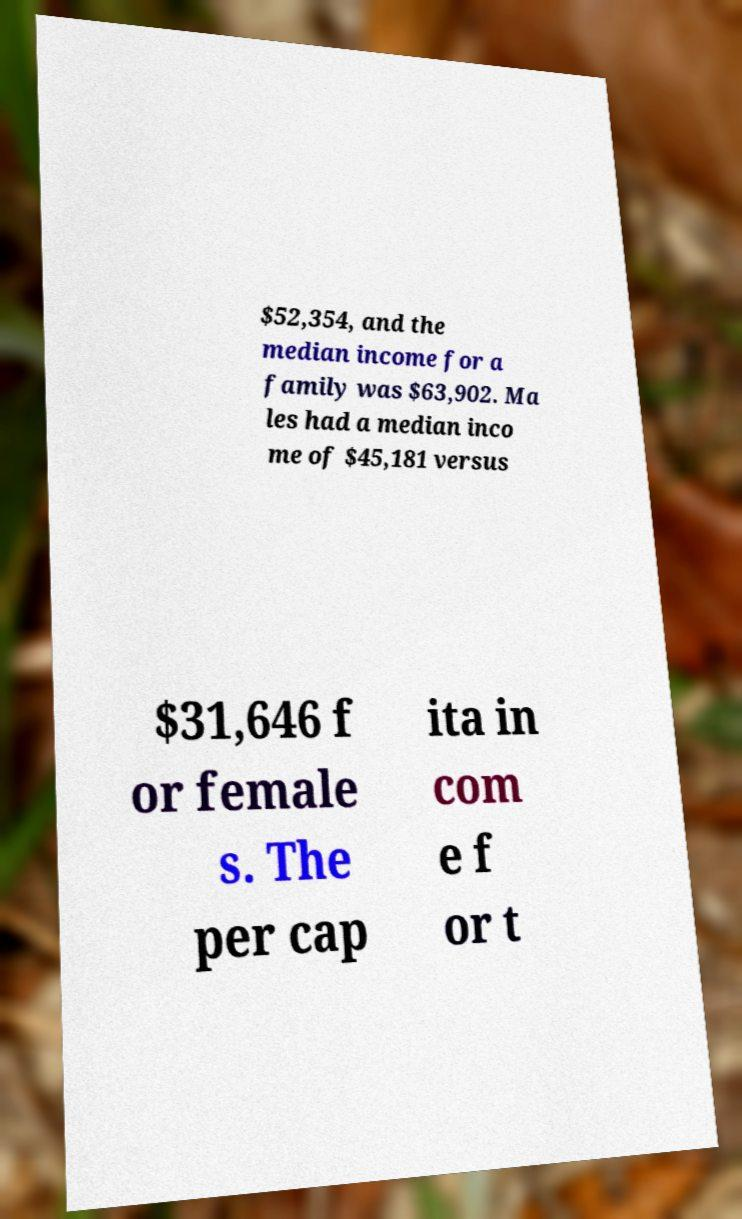Could you assist in decoding the text presented in this image and type it out clearly? $52,354, and the median income for a family was $63,902. Ma les had a median inco me of $45,181 versus $31,646 f or female s. The per cap ita in com e f or t 